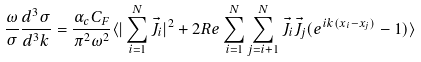<formula> <loc_0><loc_0><loc_500><loc_500>\frac { \omega } { \sigma } \frac { d ^ { 3 } \sigma } { d ^ { 3 } k } = \frac { \alpha _ { c } C _ { F } } { \pi ^ { 2 } \omega ^ { 2 } } \langle | \sum _ { i = 1 } ^ { N } \vec { J } _ { i } | ^ { 2 } + 2 R e \sum _ { i = 1 } ^ { N } \sum _ { j = i + 1 } ^ { N } \vec { J } _ { i } \vec { J } _ { j } ( e ^ { i k ( x _ { i } - x _ { j } ) } - 1 ) \rangle</formula> 